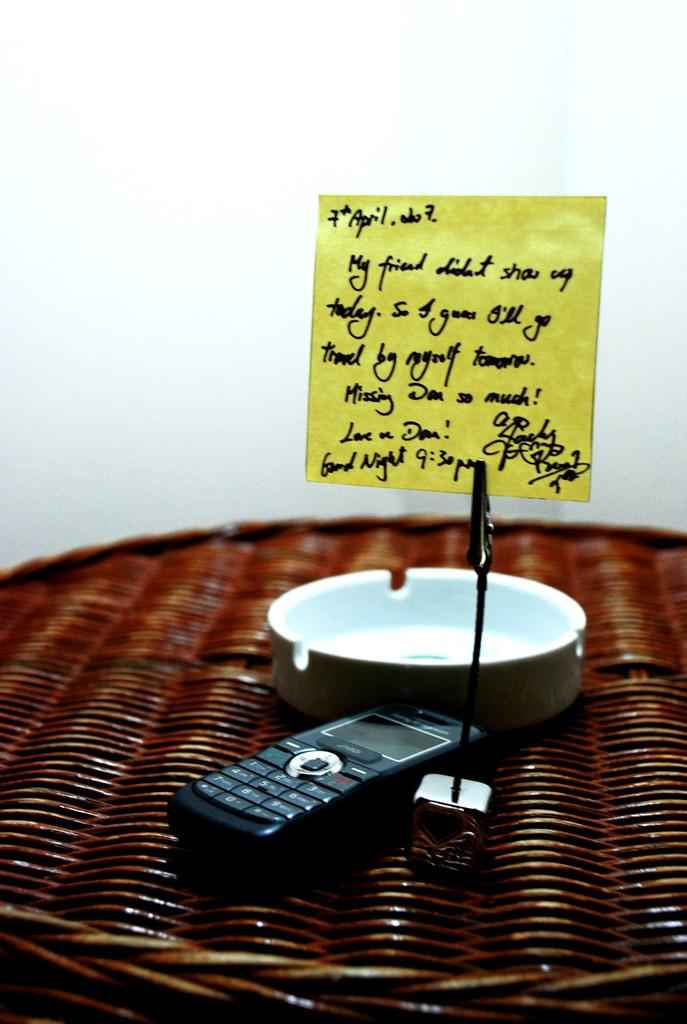What is the main object in the image? There is a mobile in the image. What else can be seen in the image besides the mobile? There is an object, a stand with a paper, and text on the paper. Where is the stand with the paper located in the image? There is a stand at the bottom of the image. What type of alarm is ringing in the image? There is no alarm present in the image. What kind of guide is being used in the image? There is no guide present in the image. 